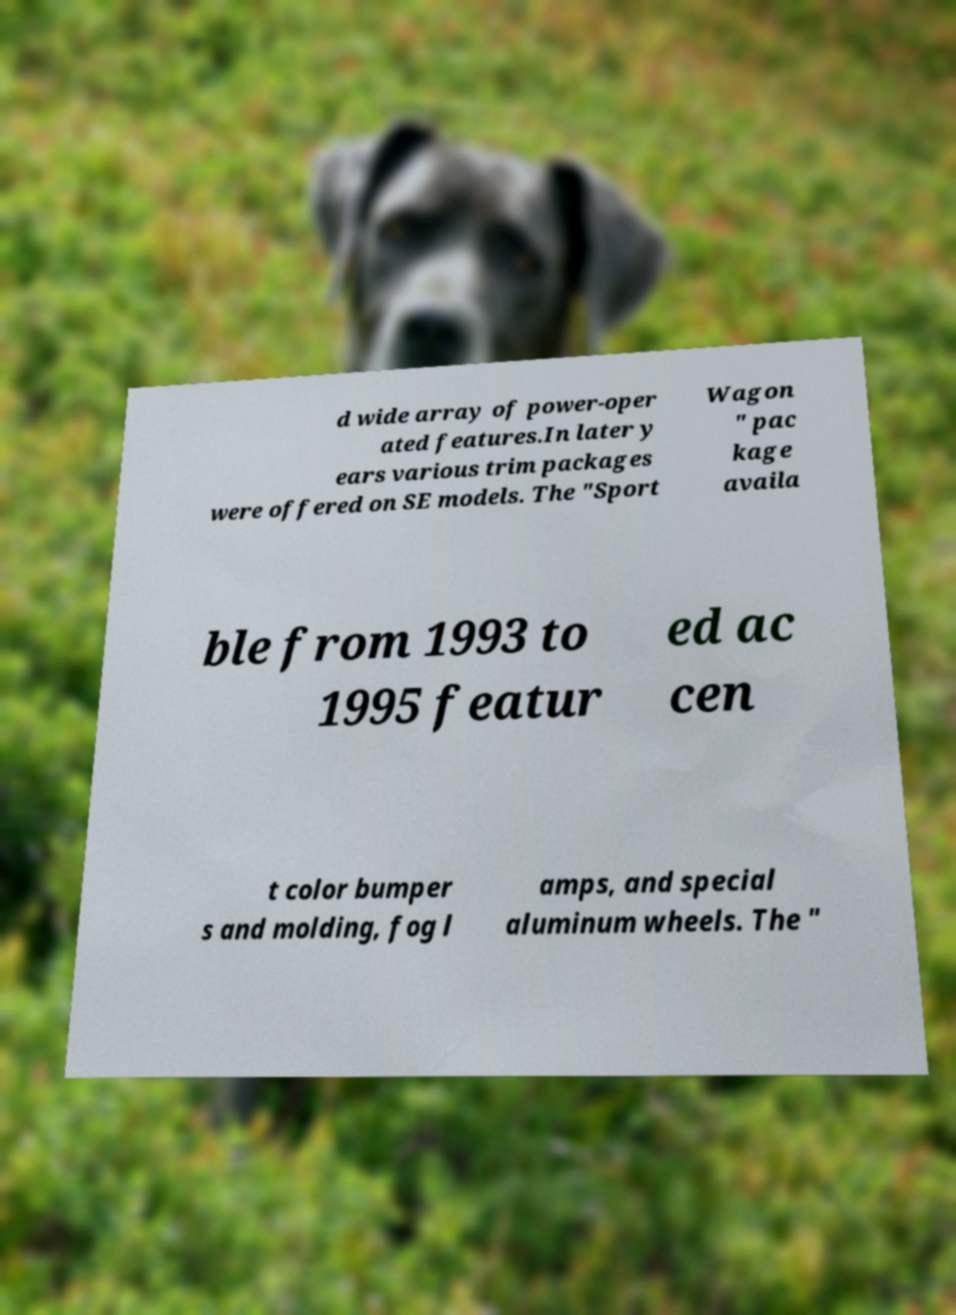Could you extract and type out the text from this image? d wide array of power-oper ated features.In later y ears various trim packages were offered on SE models. The "Sport Wagon " pac kage availa ble from 1993 to 1995 featur ed ac cen t color bumper s and molding, fog l amps, and special aluminum wheels. The " 